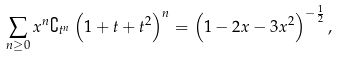Convert formula to latex. <formula><loc_0><loc_0><loc_500><loc_500>\sum _ { n \geq 0 } x ^ { n } \complement _ { t ^ { n } } \left ( 1 + t + t ^ { 2 } \right ) ^ { n } = \left ( 1 - 2 x - 3 x ^ { 2 } \right ) ^ { - \frac { 1 } { 2 } } ,</formula> 